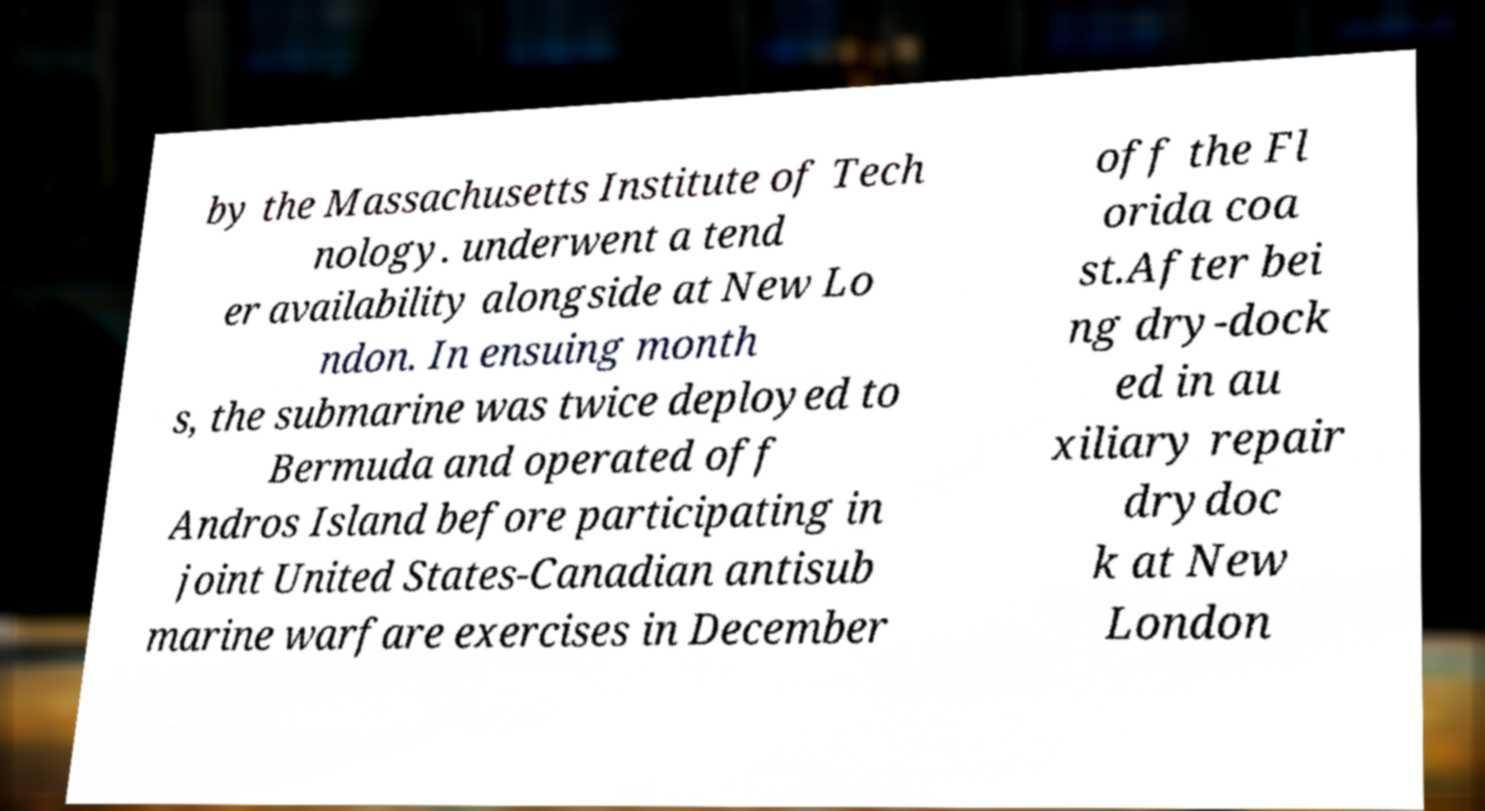Can you read and provide the text displayed in the image?This photo seems to have some interesting text. Can you extract and type it out for me? by the Massachusetts Institute of Tech nology. underwent a tend er availability alongside at New Lo ndon. In ensuing month s, the submarine was twice deployed to Bermuda and operated off Andros Island before participating in joint United States-Canadian antisub marine warfare exercises in December off the Fl orida coa st.After bei ng dry-dock ed in au xiliary repair drydoc k at New London 